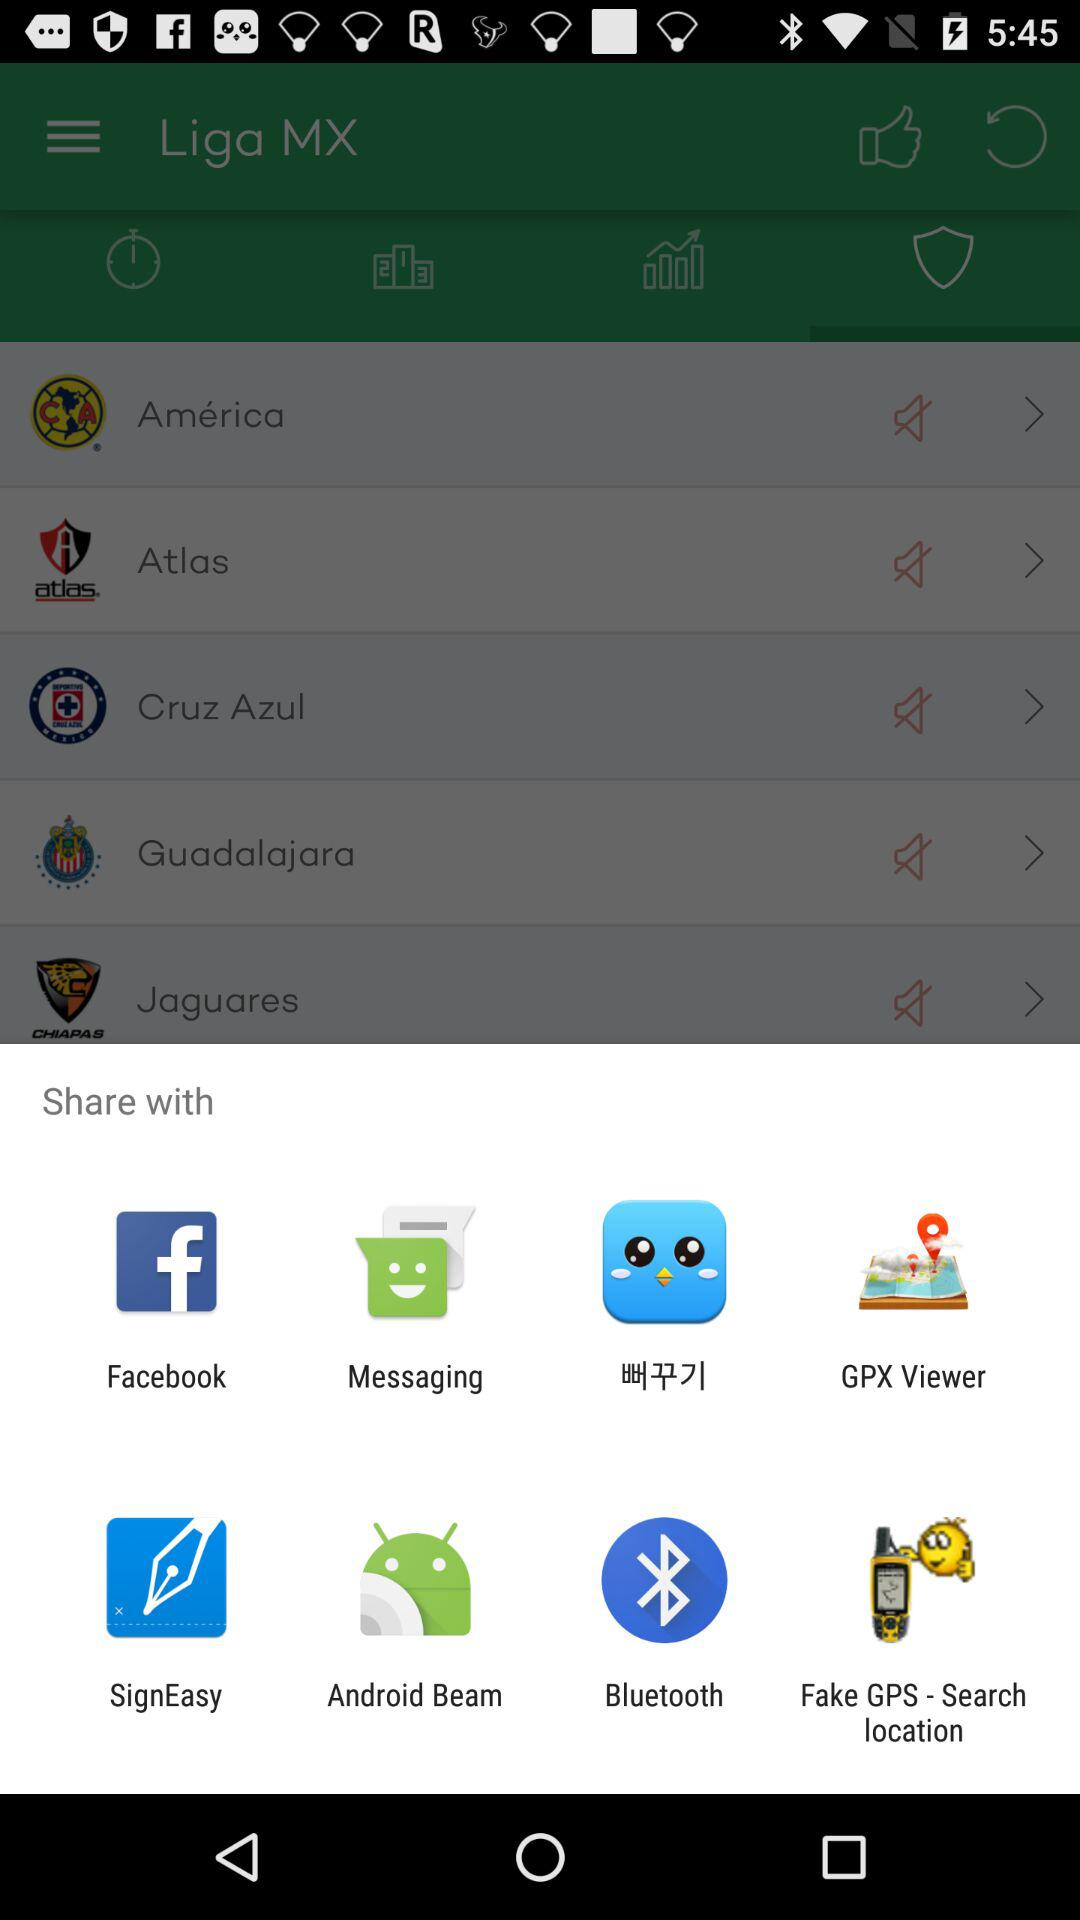What are the different mediums to share? You can share it with Facebook, Messaging, GPX Viewer, SignEasy, Android Beam, Bluetooth and Fake GPS - Search location. 